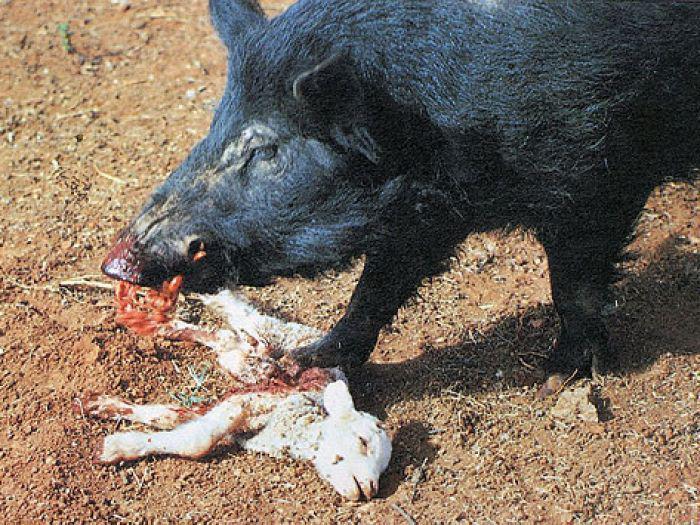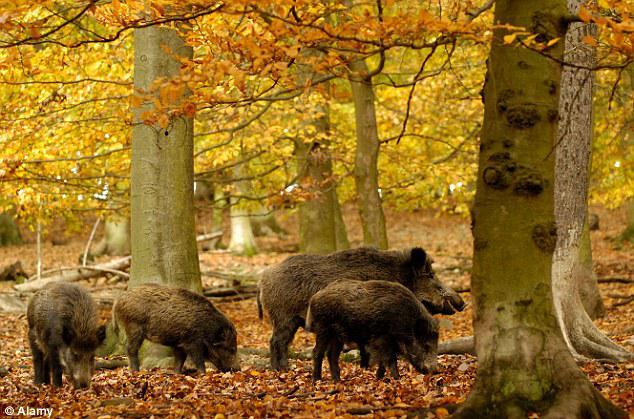The first image is the image on the left, the second image is the image on the right. Considering the images on both sides, is "An image shows one boar standing over the dead body of a hooved animal." valid? Answer yes or no. Yes. The first image is the image on the left, the second image is the image on the right. Evaluate the accuracy of this statement regarding the images: "There are at least two boars in the left image.". Is it true? Answer yes or no. No. 